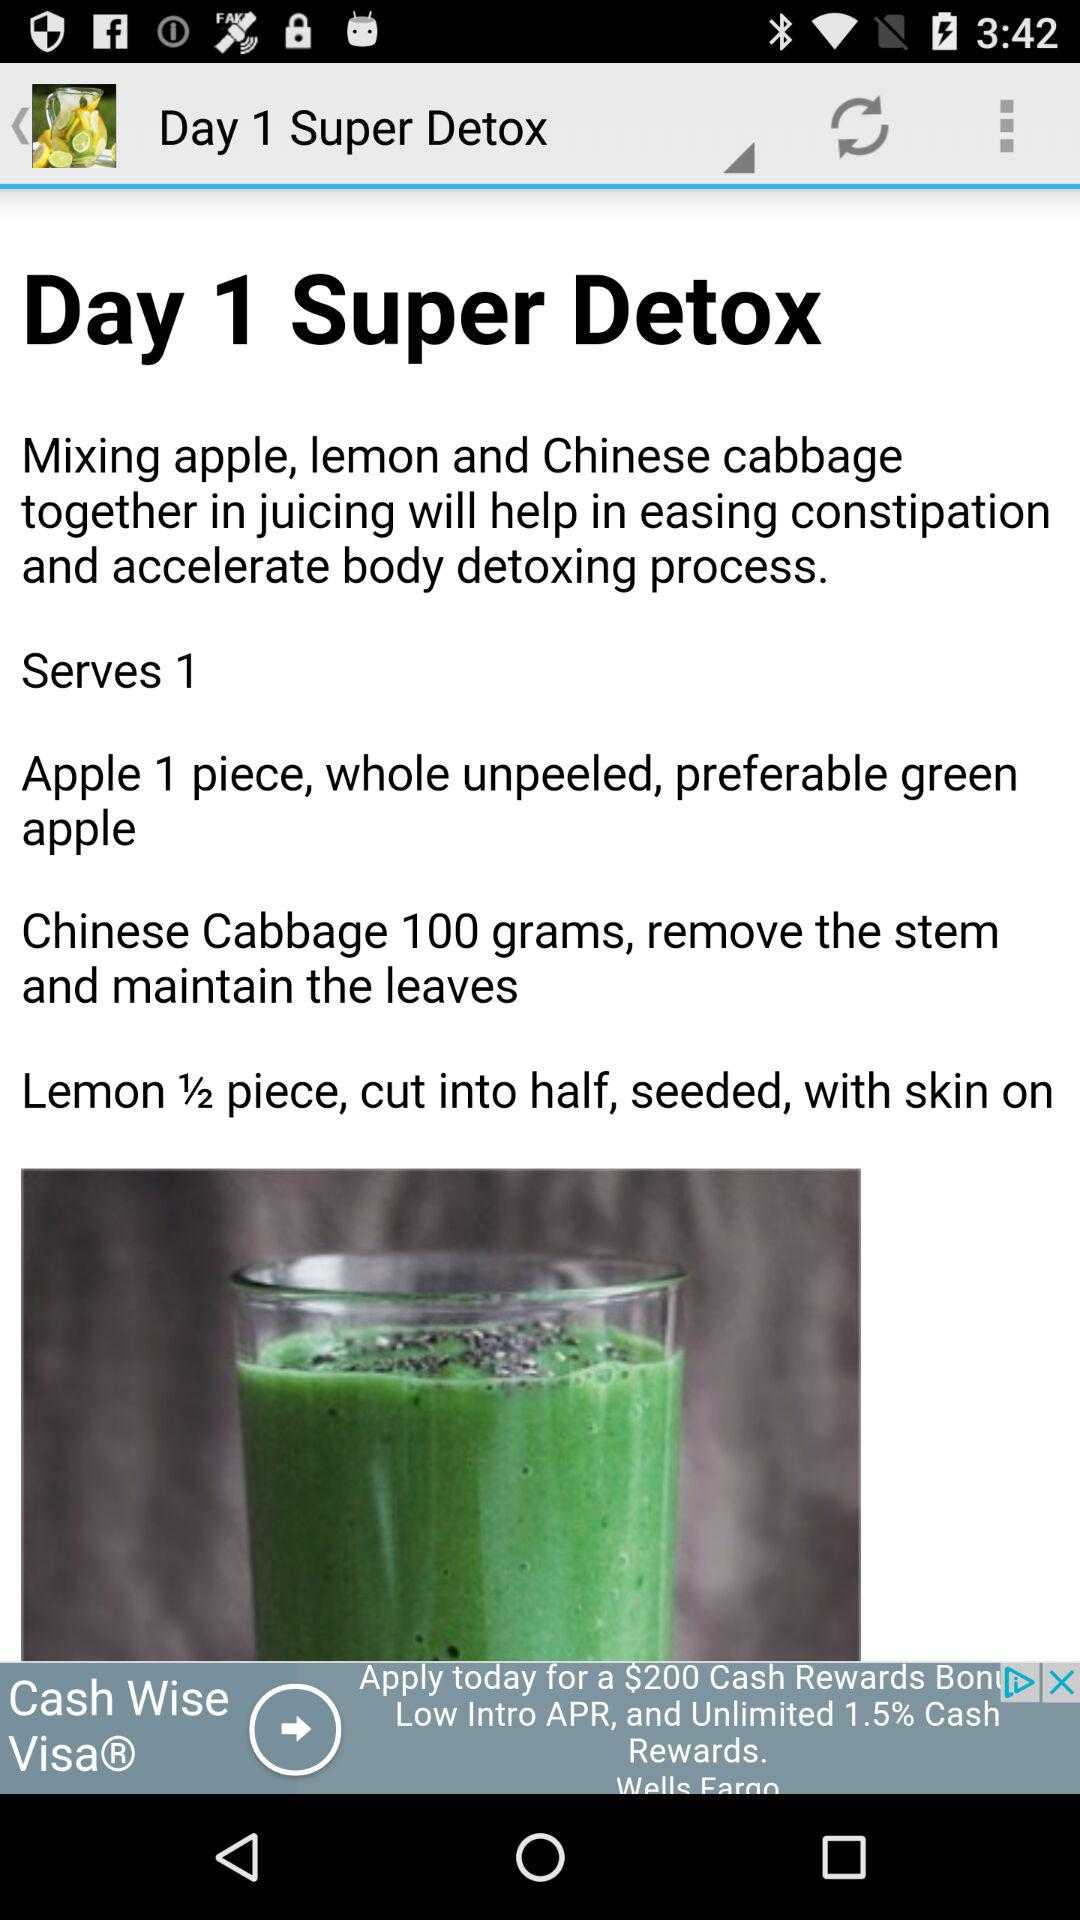What is the quantity of lemon required for the "Super Detox"? The required quantity of lemon is ½ piece. 